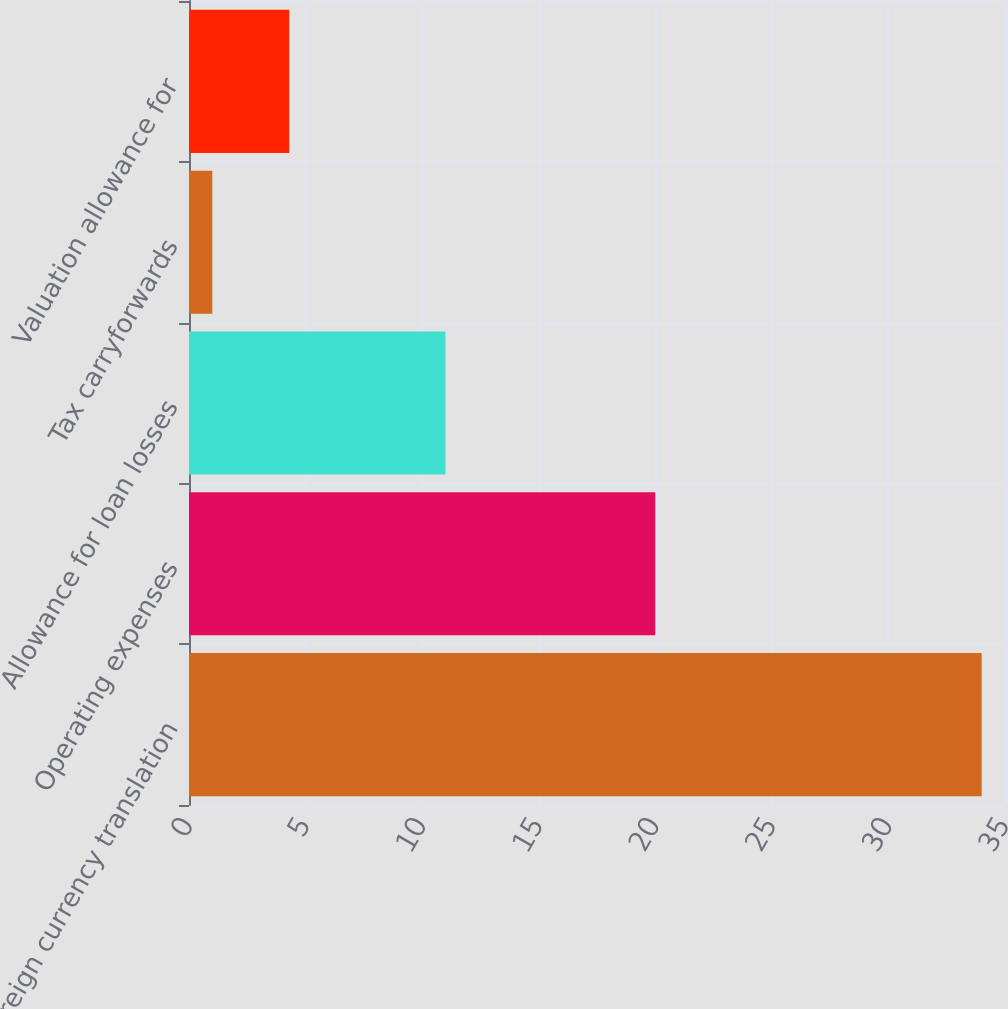<chart> <loc_0><loc_0><loc_500><loc_500><bar_chart><fcel>Foreign currency translation<fcel>Operating expenses<fcel>Allowance for loan losses<fcel>Tax carryforwards<fcel>Valuation allowance for<nl><fcel>34<fcel>20<fcel>11<fcel>1<fcel>4.3<nl></chart> 